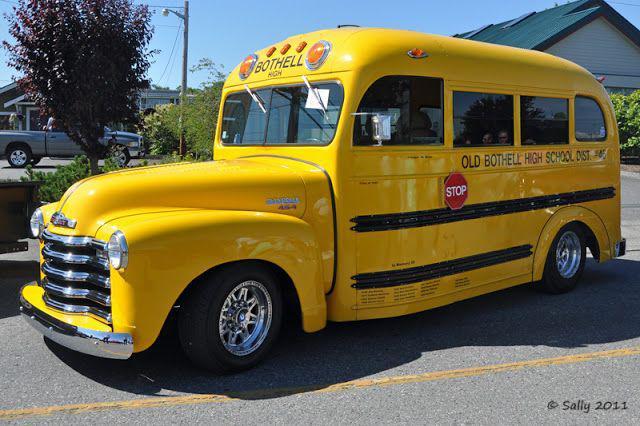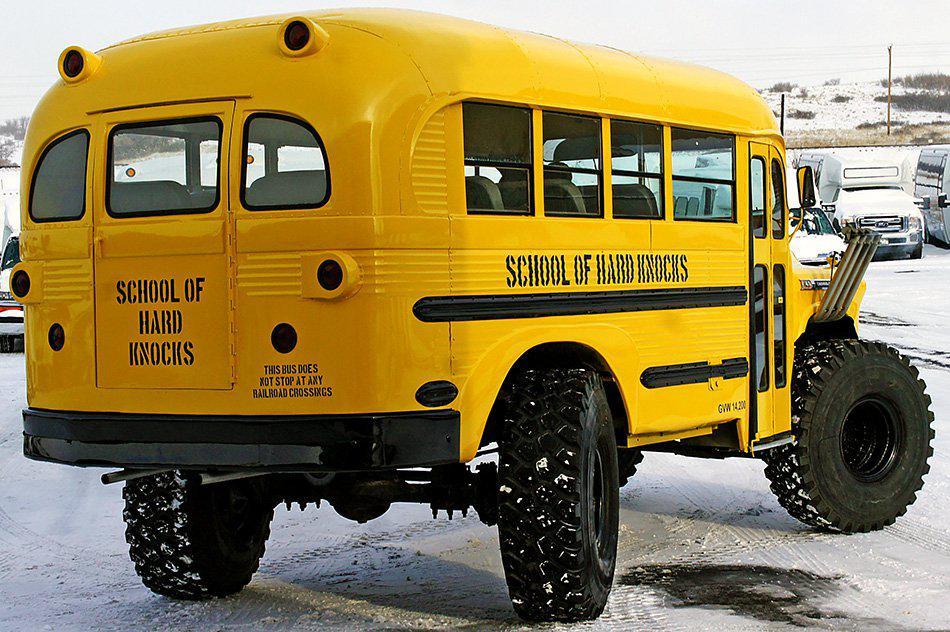The first image is the image on the left, the second image is the image on the right. Examine the images to the left and right. Is the description "The left image shows a classic-car-look short bus with three passenger windows on a side, a rounded top, and a scooped hood." accurate? Answer yes or no. Yes. The first image is the image on the left, the second image is the image on the right. Evaluate the accuracy of this statement regarding the images: "The school bus on the left has the hood of a classic car, not of a school bus.". Is it true? Answer yes or no. Yes. 